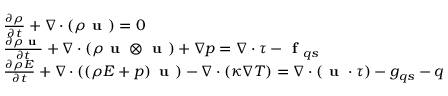<formula> <loc_0><loc_0><loc_500><loc_500>\begin{array} { r l } & { \frac { \partial \rho } { \partial t } + \nabla \cdot \left ( \rho u \right ) = 0 } \\ & { \frac { \partial \rho u } { \partial t } + \nabla \cdot \left ( \rho u \otimes u \right ) + \nabla p = \nabla \cdot \tau - f _ { q s } } \\ & { \frac { \partial \rho E } { \partial t } + \nabla \cdot \left ( \left ( \rho E + p \right ) u \right ) - \nabla \cdot \left ( \kappa \nabla T \right ) = \nabla \cdot \left ( u \cdot \tau \right ) - g _ { q s } - q } \end{array}</formula> 